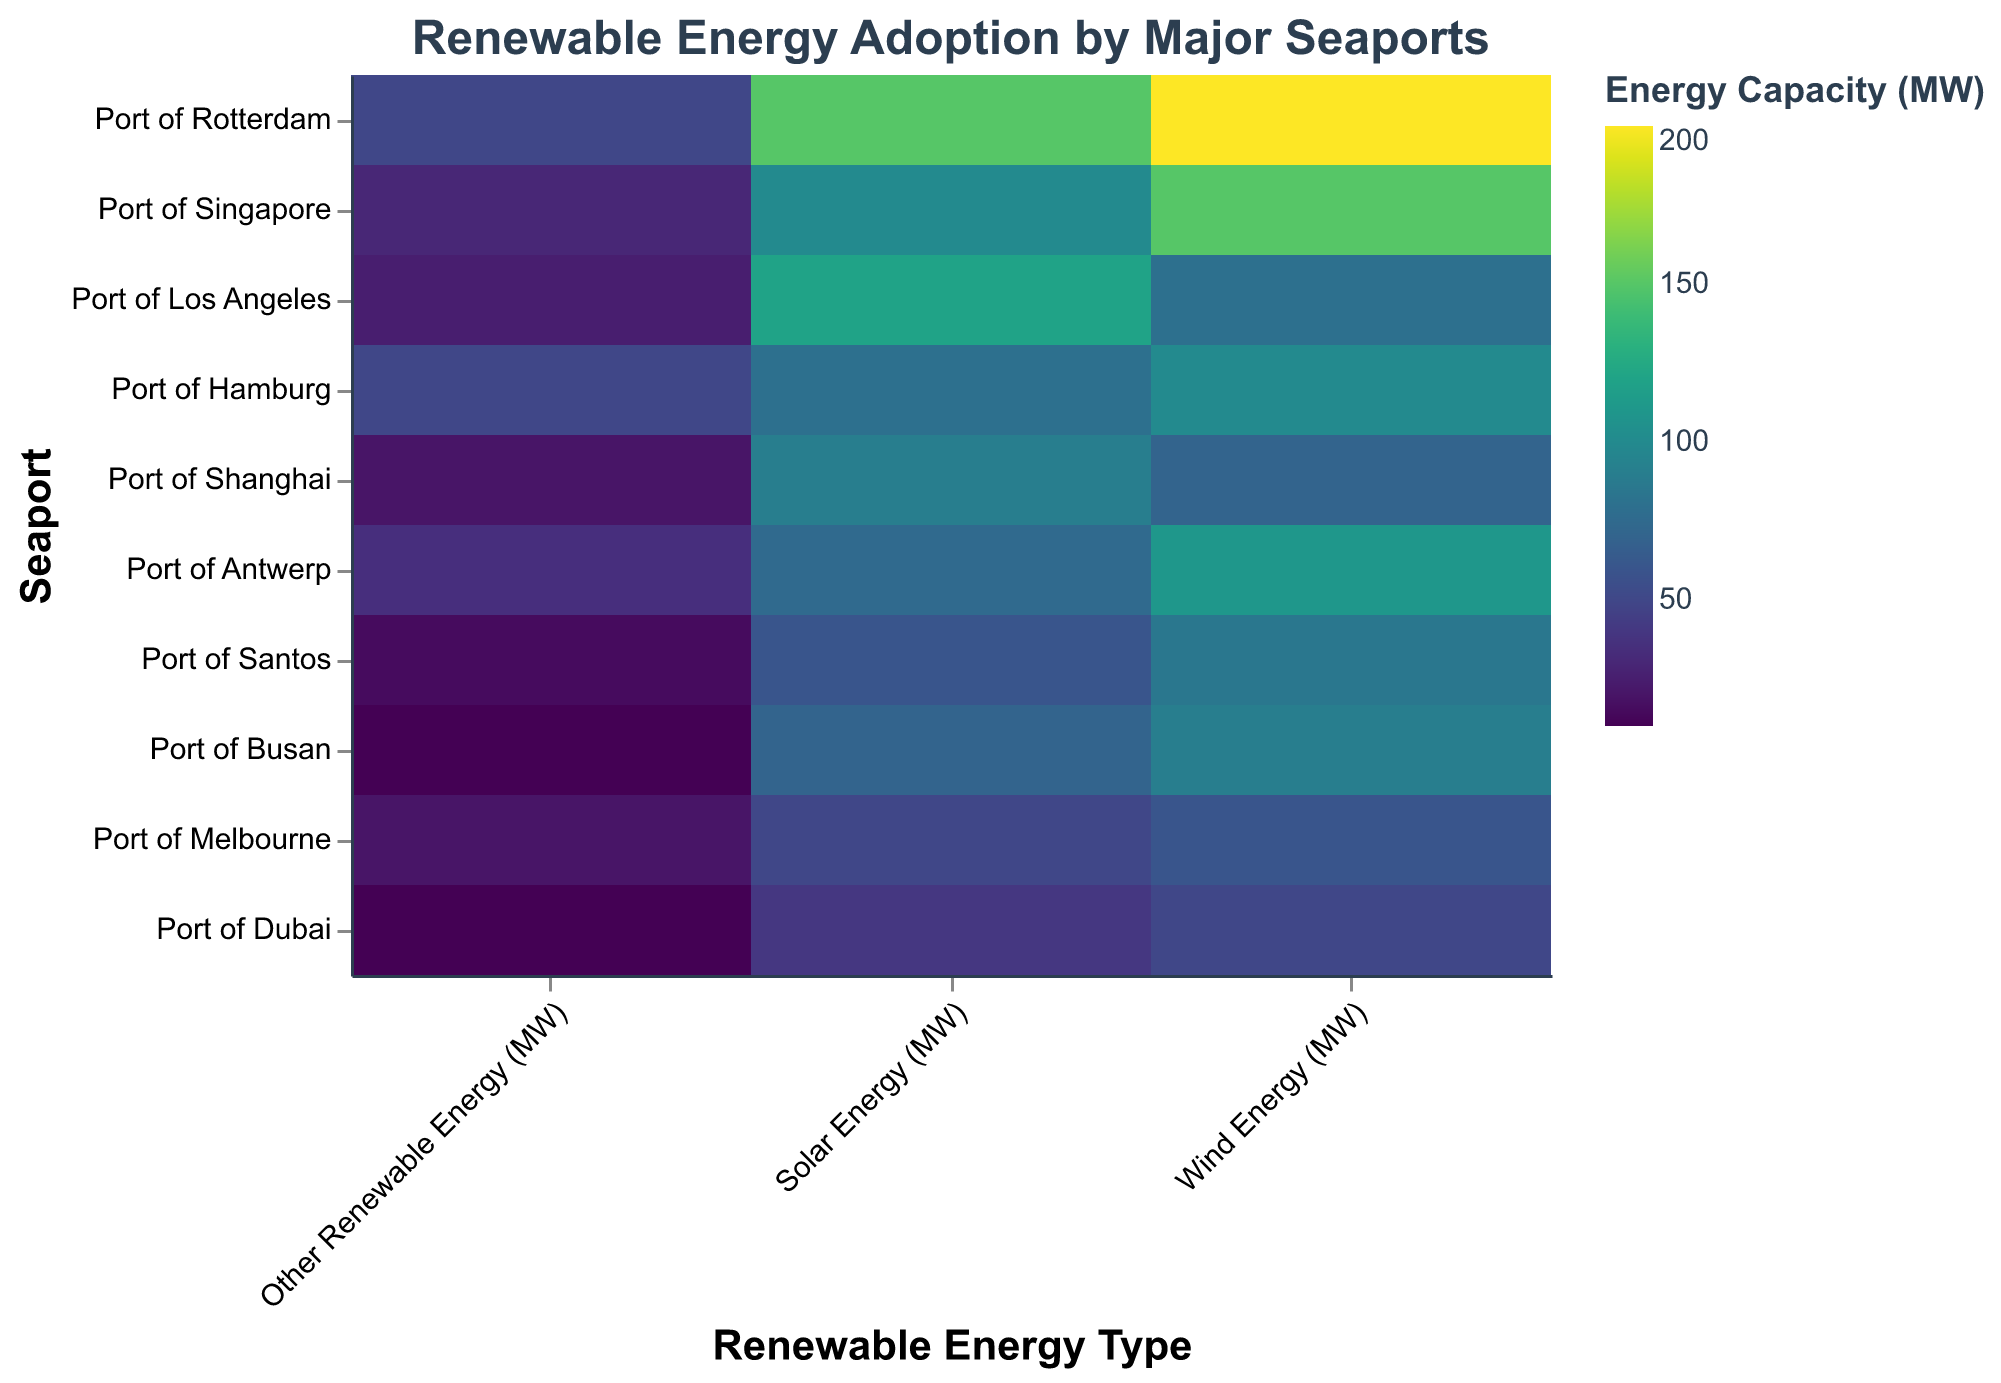Which seaport has the highest total renewable energy capacity? To find the seaport with the highest total renewable energy capacity, we sum up the Solar, Wind, and Other Renewable Energy capacities for each seaport. The Port of Rotterdam (150 + 200 + 50 = 400 MW) has the highest total renewable energy capacity.
Answer: Port of Rotterdam Which seaport in Asia has the highest solar energy capacity? To find the highest solar energy capacity among Asian seaports, we compare the values for the Port of Singapore, Port of Shanghai, and Port of Busan. The Port of Singapore has the highest solar energy capacity (100 MW).
Answer: Port of Singapore What is the average wind energy capacity across all seaports? To find the average wind energy capacity, sum the wind energy values for all seaports and divide by the number of seaports. (200 + 150 + 80 + 100 + 70 + 110 + 85 + 90 + 60 + 50) / 10 = 99.5 MW.
Answer: 99.5 MW How does the solar energy capacity of the Port of Los Angeles compare to its wind energy capacity? To compare, we look at the values for the Port of Los Angeles. The solar energy capacity (120 MW) is greater than the wind energy capacity (80 MW).
Answer: Solar energy capacity is greater Which energy type does the Port of Hamburg invest in the most? To determine the most invested energy type by the Port of Hamburg, we compare the values for solar (80 MW), wind (100 MW), and other renewable energy (50 MW). Wind energy is the highest.
Answer: Wind energy What is the total renewable energy capacity for the Port of Dubai? To find the total renewable energy capacity, sum up the solar, wind, and other renewable energy capacities for the Port of Dubai (40 + 50 + 10 = 100 MW).
Answer: 100 MW Which country’s seaport has the lowest total renewable energy capacity? To determine the lowest total renewable energy capacity, sum up the solar, wind, and other renewable energy capacities for each seaport and find the minimum. Port of Dubai (40 + 50 + 10 = 100 MW) is the lowest.
Answer: UAE What is the most adopted renewable energy type across all seaports? To find the most adopted energy type, we sum the capacities for solar, wind, and other renewable energy across all seaports. The highest total is wind energy (995 MW).
Answer: Wind energy How does the renewable energy composition of the Port of Antwerp compare to the Port of Hamburg? To compare, evaluate the solar, wind, and other renewable energy capacities for both ports. Port of Antwerp: 75 MW solar, 110 MW wind, 35 MW others. Port of Hamburg: 80 MW solar, 100 MW wind, 50 MW others. The Port of Antwerp has higher wind and lower solar and other renewable energy capacities compared to the Port of Hamburg.
Answer: Antwerp has higher wind, lower solar and other renewable energy 